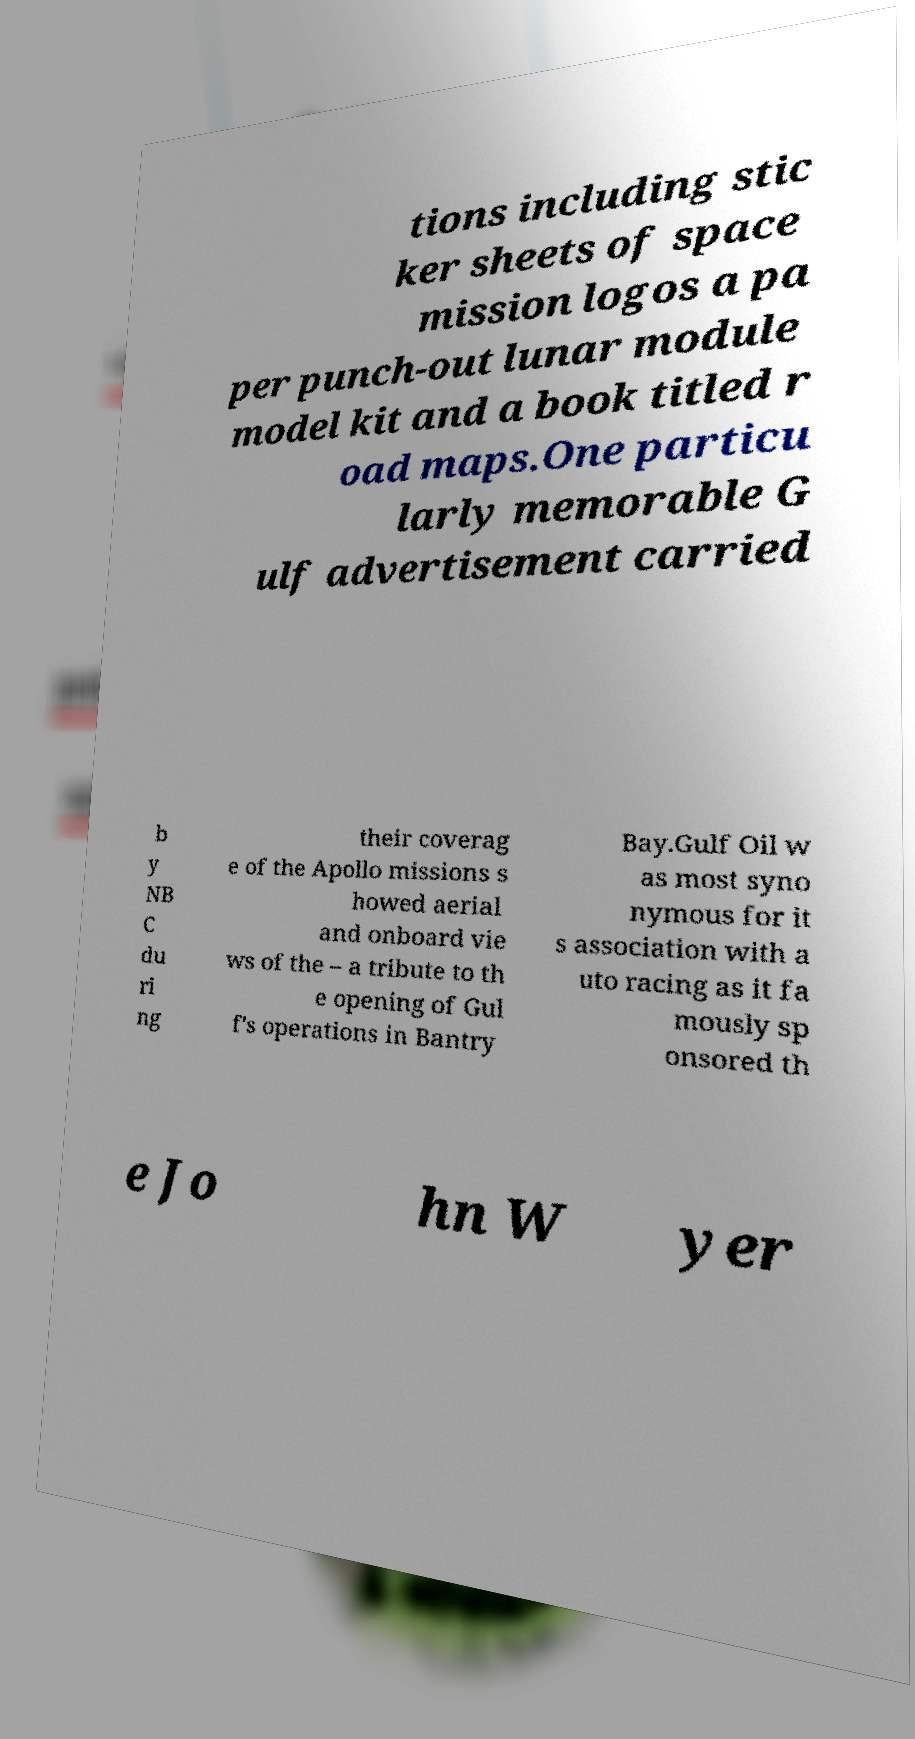What messages or text are displayed in this image? I need them in a readable, typed format. tions including stic ker sheets of space mission logos a pa per punch-out lunar module model kit and a book titled r oad maps.One particu larly memorable G ulf advertisement carried b y NB C du ri ng their coverag e of the Apollo missions s howed aerial and onboard vie ws of the – a tribute to th e opening of Gul f's operations in Bantry Bay.Gulf Oil w as most syno nymous for it s association with a uto racing as it fa mously sp onsored th e Jo hn W yer 